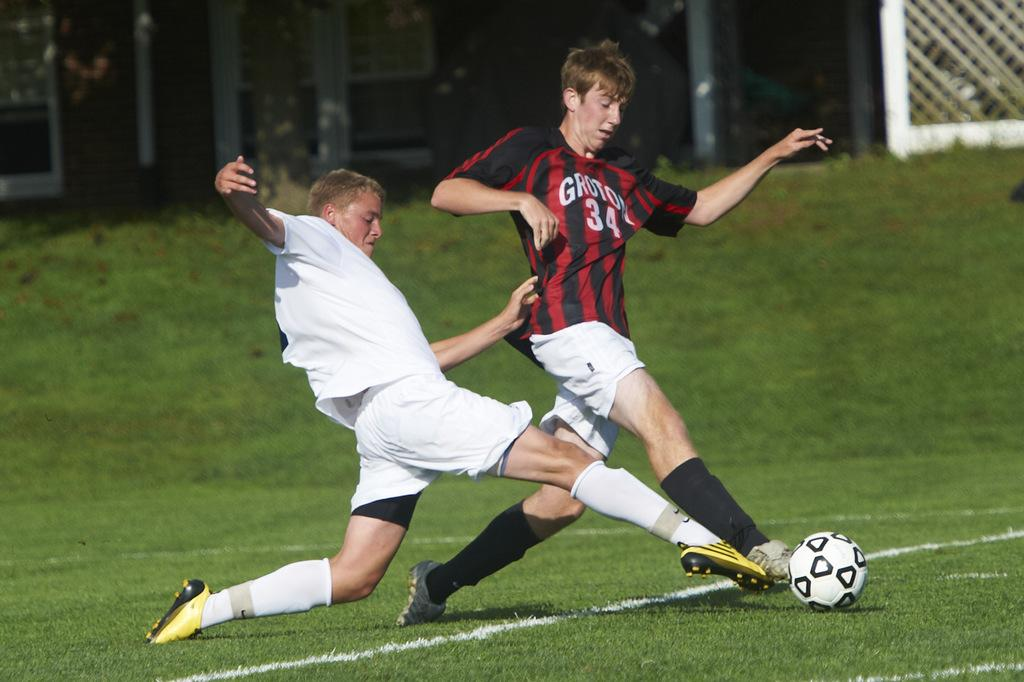How many people are in the image? There are two persons in the image. What are the two persons doing in the image? The two persons are playing with a ball. What type of surface can be seen in the image? There is grass visible in the image. What type of button can be seen on the cemetery in the image? There is no cemetery or button present in the image. Can you tell me the relationship between the two persons in the image? The provided facts do not mention the relationship between the two persons, so we cannot determine their relationship from the image. 